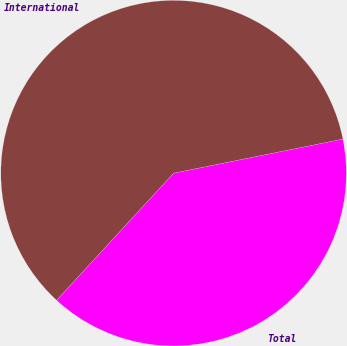Convert chart to OTSL. <chart><loc_0><loc_0><loc_500><loc_500><pie_chart><fcel>Total<fcel>International<nl><fcel>40.0%<fcel>60.0%<nl></chart> 